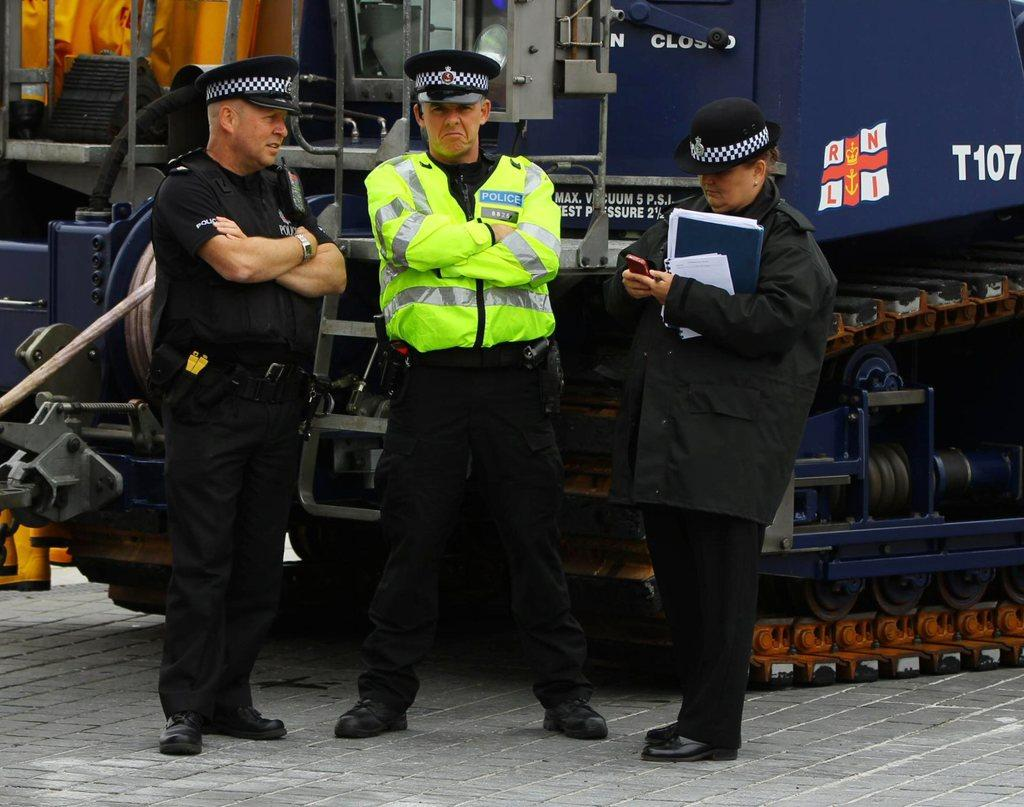What is happening in the image? There are persons standing in the image. What can be seen in the background of the image? There is a vehicle in the background of the image. Can you describe the woman in the image? There is a woman standing in the image, and she is holding objects in her hand. What type of squirrel can be seen climbing the woman's leg in the image? There is no squirrel present in the image; the woman is simply holding objects in her hand. How many oranges are visible in the image? There is no mention of oranges in the image; the focus is on the persons standing and the woman holding objects. 